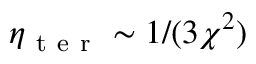Convert formula to latex. <formula><loc_0><loc_0><loc_500><loc_500>\eta _ { t e r } \sim 1 / ( 3 \chi ^ { 2 } )</formula> 